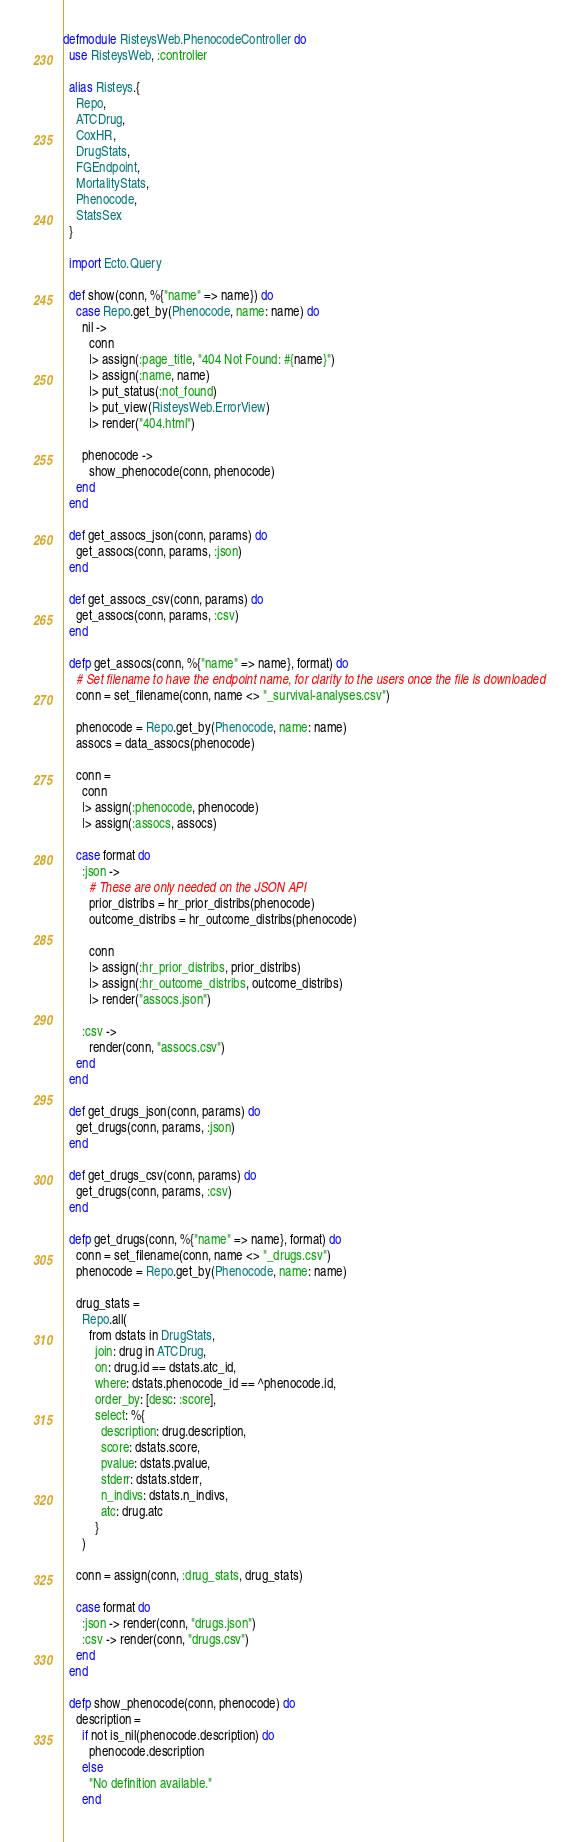Convert code to text. <code><loc_0><loc_0><loc_500><loc_500><_Elixir_>defmodule RisteysWeb.PhenocodeController do
  use RisteysWeb, :controller

  alias Risteys.{
    Repo,
    ATCDrug,
    CoxHR,
    DrugStats,
    FGEndpoint,
    MortalityStats,
    Phenocode,
    StatsSex
  }

  import Ecto.Query

  def show(conn, %{"name" => name}) do
    case Repo.get_by(Phenocode, name: name) do
      nil ->
        conn
        |> assign(:page_title, "404 Not Found: #{name}")
        |> assign(:name, name)
        |> put_status(:not_found)
        |> put_view(RisteysWeb.ErrorView)
        |> render("404.html")

      phenocode ->
        show_phenocode(conn, phenocode)
    end
  end

  def get_assocs_json(conn, params) do
    get_assocs(conn, params, :json)
  end

  def get_assocs_csv(conn, params) do
    get_assocs(conn, params, :csv)
  end

  defp get_assocs(conn, %{"name" => name}, format) do
    # Set filename to have the endpoint name, for clarity to the users once the file is downloaded
    conn = set_filename(conn, name <> "_survival-analyses.csv")

    phenocode = Repo.get_by(Phenocode, name: name)
    assocs = data_assocs(phenocode)

    conn =
      conn
      |> assign(:phenocode, phenocode)
      |> assign(:assocs, assocs)

    case format do
      :json ->
        # These are only needed on the JSON API
        prior_distribs = hr_prior_distribs(phenocode)
        outcome_distribs = hr_outcome_distribs(phenocode)

        conn
        |> assign(:hr_prior_distribs, prior_distribs)
        |> assign(:hr_outcome_distribs, outcome_distribs)
        |> render("assocs.json")

      :csv ->
        render(conn, "assocs.csv")
    end
  end

  def get_drugs_json(conn, params) do
    get_drugs(conn, params, :json)
  end

  def get_drugs_csv(conn, params) do
    get_drugs(conn, params, :csv)
  end

  defp get_drugs(conn, %{"name" => name}, format) do
    conn = set_filename(conn, name <> "_drugs.csv")
    phenocode = Repo.get_by(Phenocode, name: name)

    drug_stats =
      Repo.all(
        from dstats in DrugStats,
          join: drug in ATCDrug,
          on: drug.id == dstats.atc_id,
          where: dstats.phenocode_id == ^phenocode.id,
          order_by: [desc: :score],
          select: %{
            description: drug.description,
            score: dstats.score,
            pvalue: dstats.pvalue,
            stderr: dstats.stderr,
            n_indivs: dstats.n_indivs,
            atc: drug.atc
          }
      )

    conn = assign(conn, :drug_stats, drug_stats)

    case format do
      :json -> render(conn, "drugs.json")
      :csv -> render(conn, "drugs.csv")
    end
  end

  defp show_phenocode(conn, phenocode) do
    description =
      if not is_nil(phenocode.description) do
        phenocode.description
      else
        "No definition available."
      end
</code> 